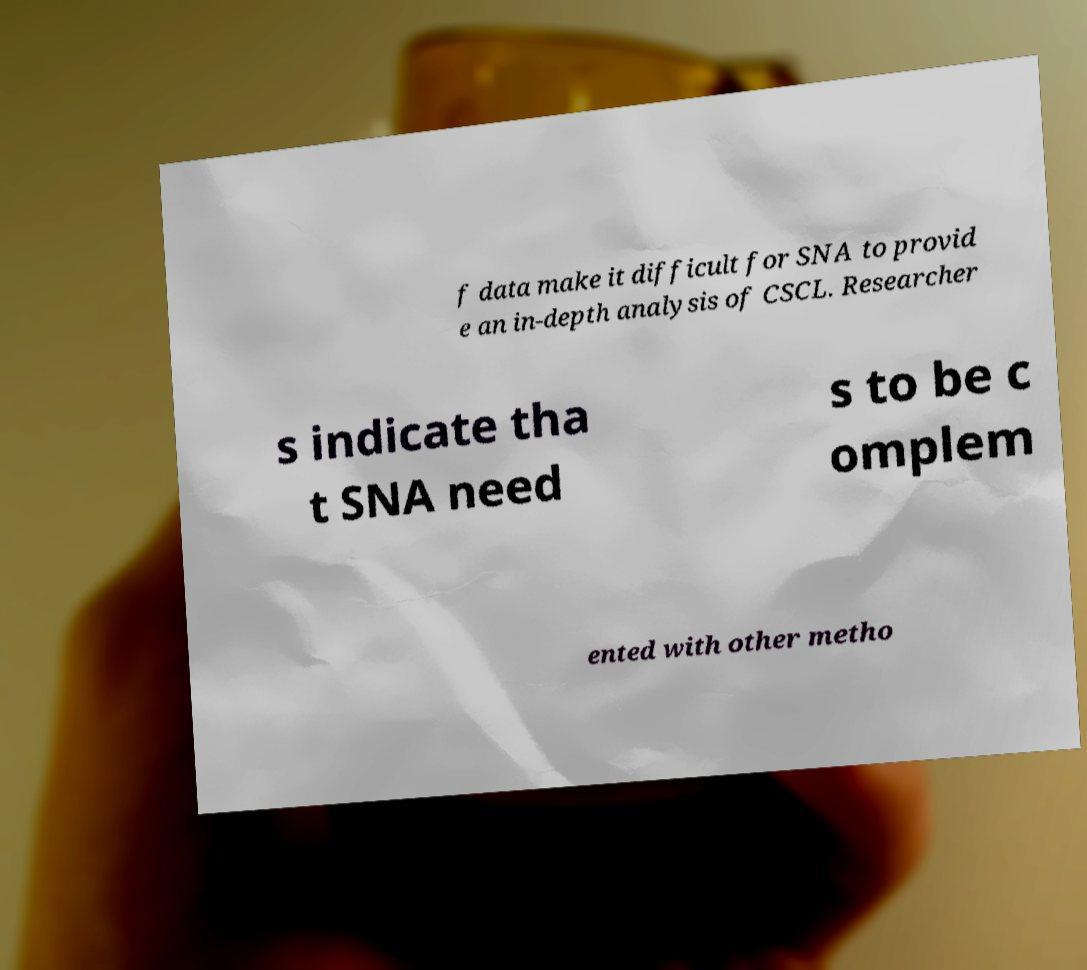Could you extract and type out the text from this image? f data make it difficult for SNA to provid e an in-depth analysis of CSCL. Researcher s indicate tha t SNA need s to be c omplem ented with other metho 